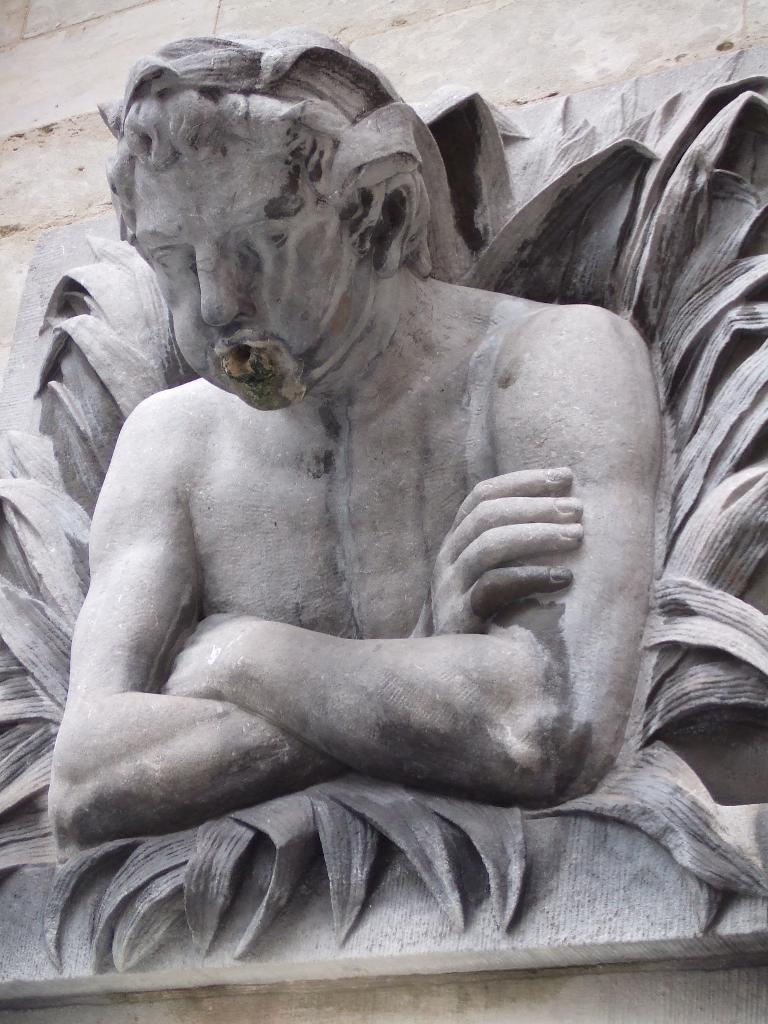What is the main subject of the image? There is a sculpture of a person in the image. Can you describe the sculpture in more detail? Unfortunately, the provided facts do not give any additional details about the sculpture. What else can be seen in the image besides the sculpture? There are other objects in the background of the image. How many babies are present in the image? There is no mention of babies in the provided facts, so we cannot determine their presence in the image. 